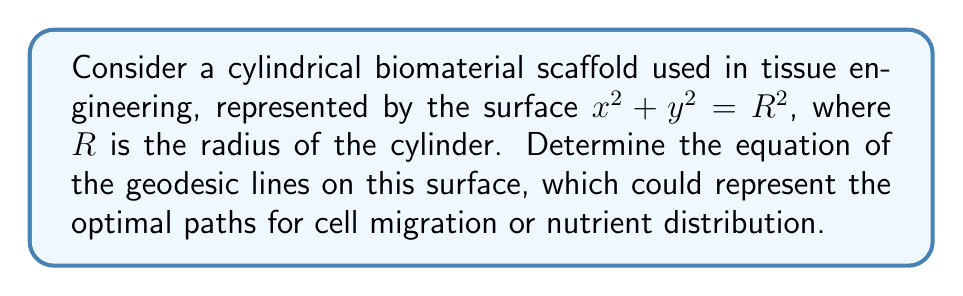What is the answer to this math problem? To find the geodesic lines on the cylindrical surface, we'll follow these steps:

1) First, we parameterize the surface. Let:
   $x = R\cos\theta$
   $y = R\sin\theta$
   $z = z$

2) The metric tensor for this surface is:
   $$g = \begin{pmatrix}
   R^2 & 0 \\
   0 & 1
   \end{pmatrix}$$

3) The geodesic equations are:
   $$\frac{d^2\theta}{ds^2} + \Gamma^\theta_{\theta\theta}\left(\frac{d\theta}{ds}\right)^2 + 2\Gamma^\theta_{\theta z}\frac{d\theta}{ds}\frac{dz}{ds} + \Gamma^\theta_{zz}\left(\frac{dz}{ds}\right)^2 = 0$$
   $$\frac{d^2z}{ds^2} + \Gamma^z_{\theta\theta}\left(\frac{d\theta}{ds}\right)^2 + 2\Gamma^z_{\theta z}\frac{d\theta}{ds}\frac{dz}{ds} + \Gamma^z_{zz}\left(\frac{dz}{ds}\right)^2 = 0$$

4) For this surface, all Christoffel symbols are zero except:
   $\Gamma^\theta_{zz} = \Gamma^z_{\theta z} = \Gamma^z_{z\theta} = 0$

5) This simplifies our geodesic equations to:
   $$\frac{d^2\theta}{ds^2} = 0$$
   $$\frac{d^2z}{ds^2} = 0$$

6) Integrating these equations, we get:
   $$\theta = as + b$$
   $$z = cs + d$$

   where $a$, $b$, $c$, and $d$ are constants.

7) This means that the geodesics are helices on the cylinder, which can be described by the equation:
   $$z = k\theta + m$$
   where $k = c/a$ and $m = d - cb/a$ are constants.

8) In Cartesian coordinates, this becomes:
   $$z = k \arctan(y/x) + m$$
Answer: $z = k \arctan(y/x) + m$, where $k$ and $m$ are constants. 